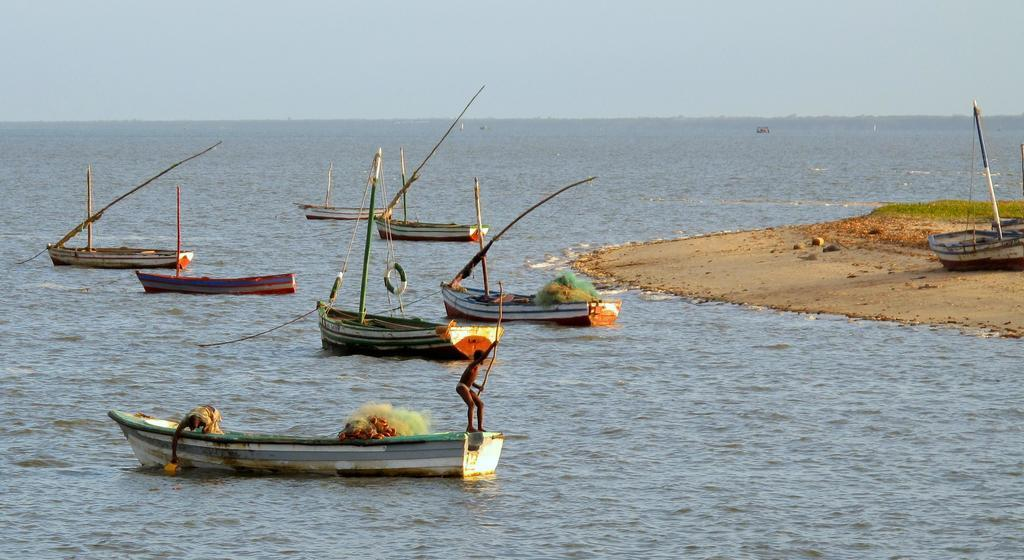What is on the water in the image? There are boats on the water in the image. How many boats are on the seashore? There are two boats on the seashore. What are the two persons holding in the image? The two persons are holding objects. What can be seen in the background of the image? The sky is visible in the background. What type of baseball equipment can be seen in the image? There is no baseball equipment present in the image. Is there a stream visible in the image? There is no stream visible in the image; it features boats on the water and the seashore. 